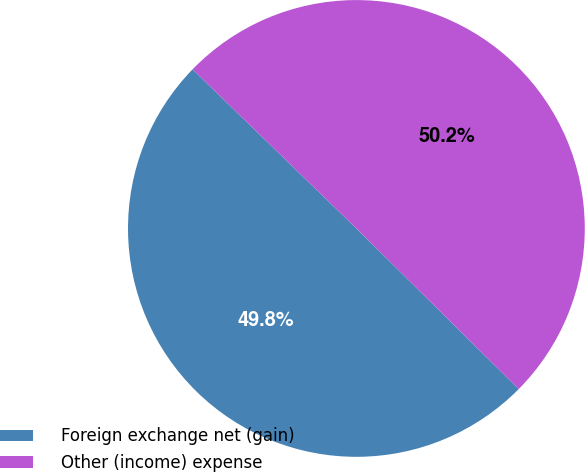Convert chart to OTSL. <chart><loc_0><loc_0><loc_500><loc_500><pie_chart><fcel>Foreign exchange net (gain)<fcel>Other (income) expense<nl><fcel>49.85%<fcel>50.15%<nl></chart> 